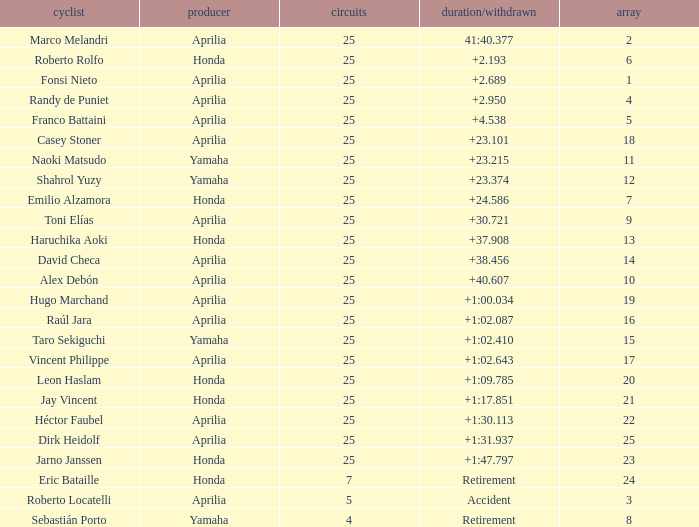Which Grid has Laps of 25, and a Manufacturer of honda, and a Time/Retired of +1:47.797? 23.0. 